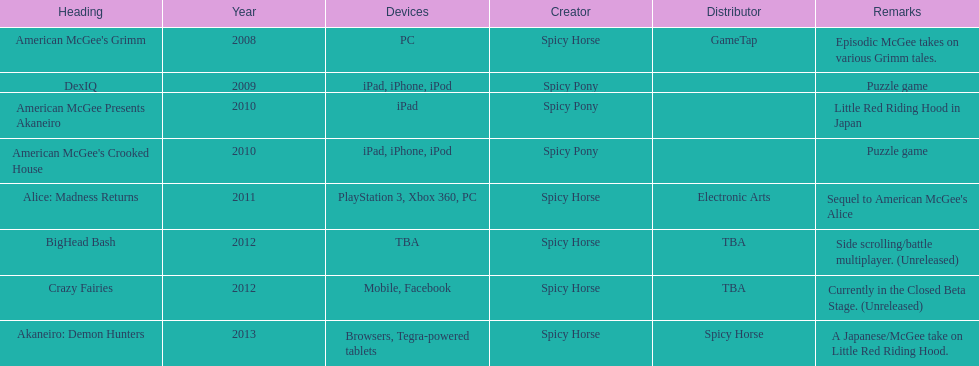What platform was employed for the last title in this graph? Browsers, Tegra-powered tablets. 